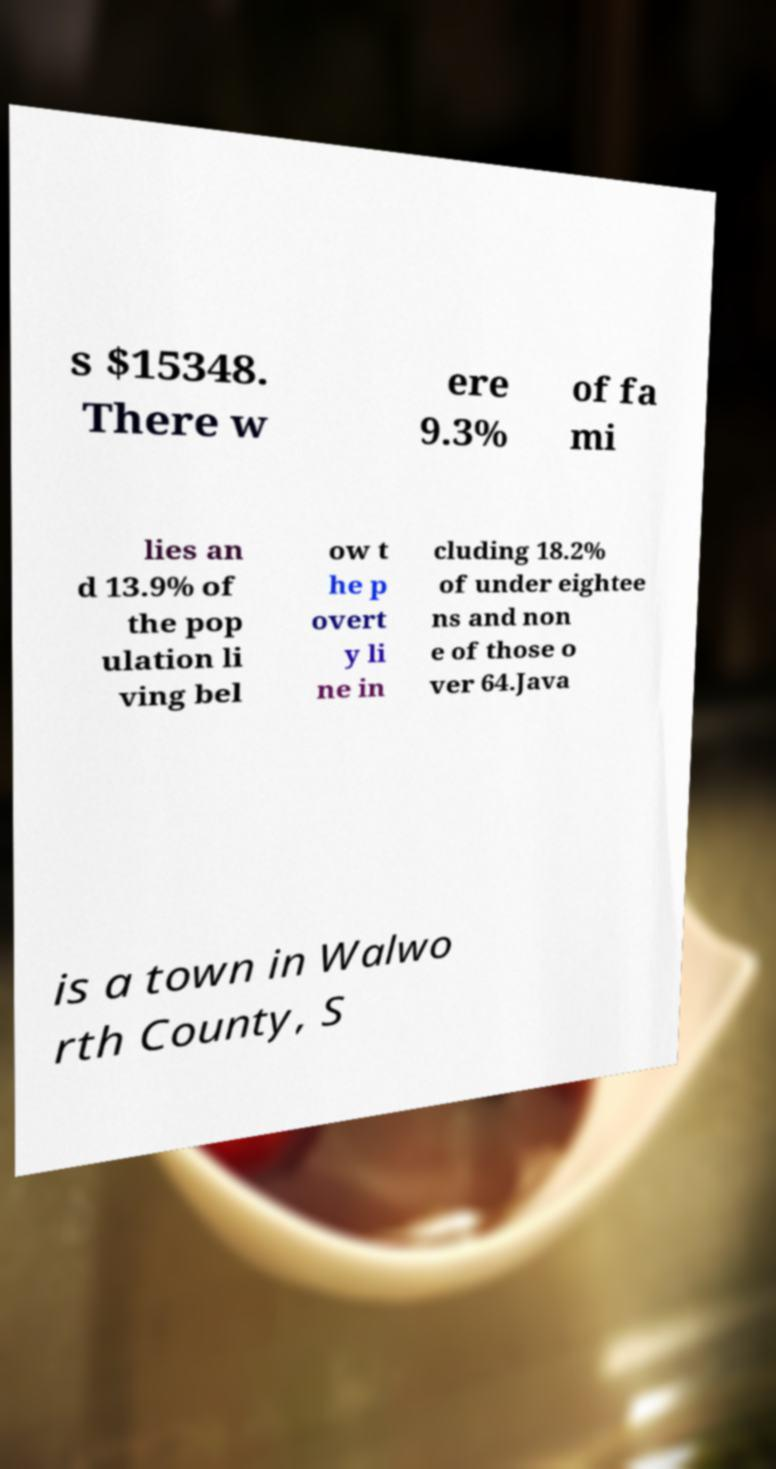Can you read and provide the text displayed in the image?This photo seems to have some interesting text. Can you extract and type it out for me? s $15348. There w ere 9.3% of fa mi lies an d 13.9% of the pop ulation li ving bel ow t he p overt y li ne in cluding 18.2% of under eightee ns and non e of those o ver 64.Java is a town in Walwo rth County, S 